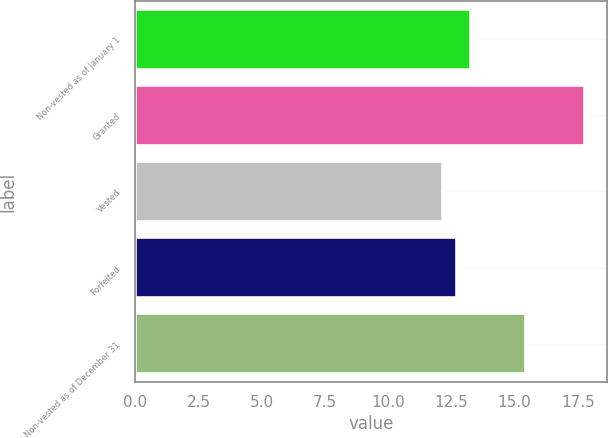<chart> <loc_0><loc_0><loc_500><loc_500><bar_chart><fcel>Non-vested as of January 1<fcel>Granted<fcel>Vested<fcel>Forfeited<fcel>Non-vested as of December 31<nl><fcel>13.27<fcel>17.77<fcel>12.15<fcel>12.71<fcel>15.47<nl></chart> 